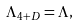<formula> <loc_0><loc_0><loc_500><loc_500>\Lambda _ { 4 + D } = \Lambda ,</formula> 